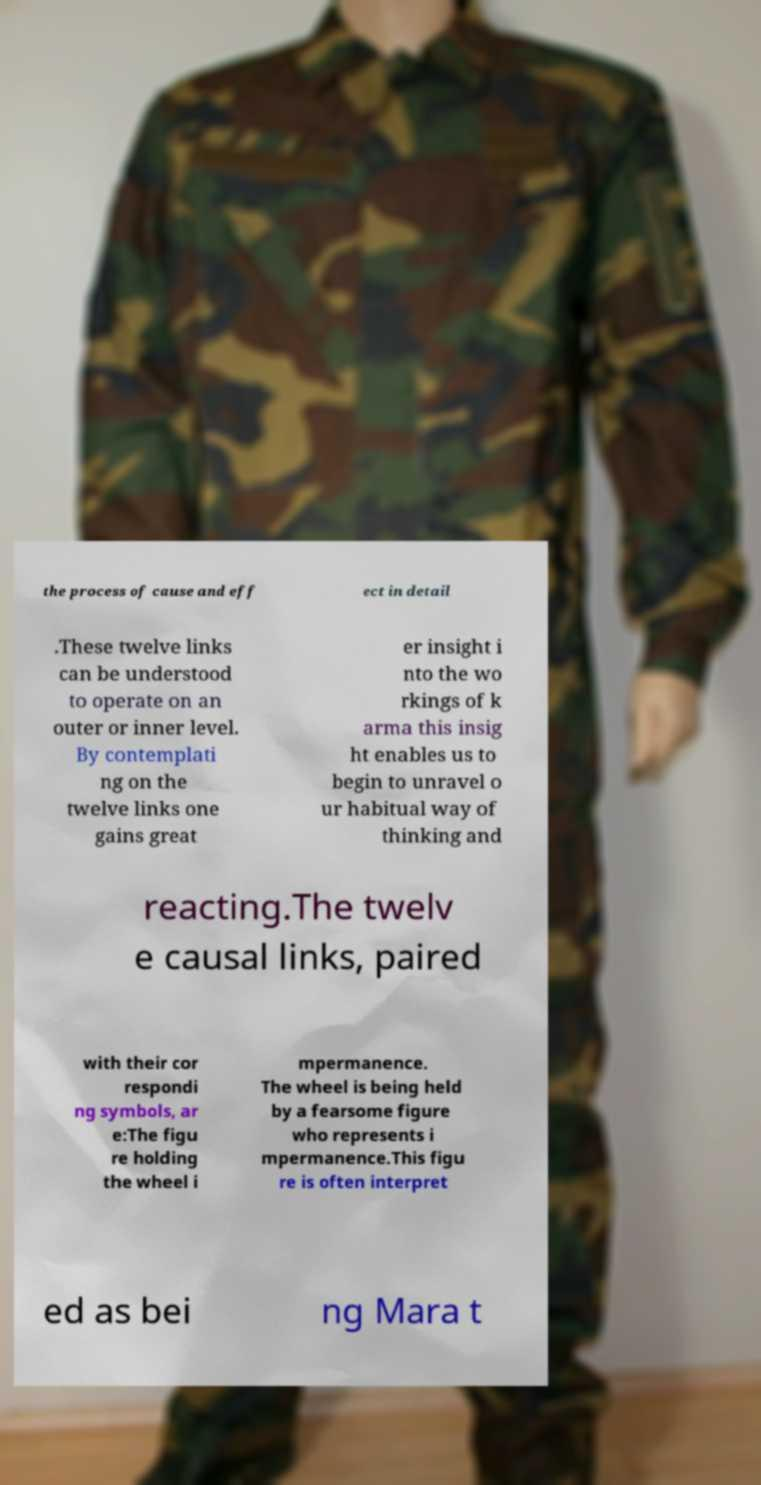Please identify and transcribe the text found in this image. the process of cause and eff ect in detail .These twelve links can be understood to operate on an outer or inner level. By contemplati ng on the twelve links one gains great er insight i nto the wo rkings of k arma this insig ht enables us to begin to unravel o ur habitual way of thinking and reacting.The twelv e causal links, paired with their cor respondi ng symbols, ar e:The figu re holding the wheel i mpermanence. The wheel is being held by a fearsome figure who represents i mpermanence.This figu re is often interpret ed as bei ng Mara t 